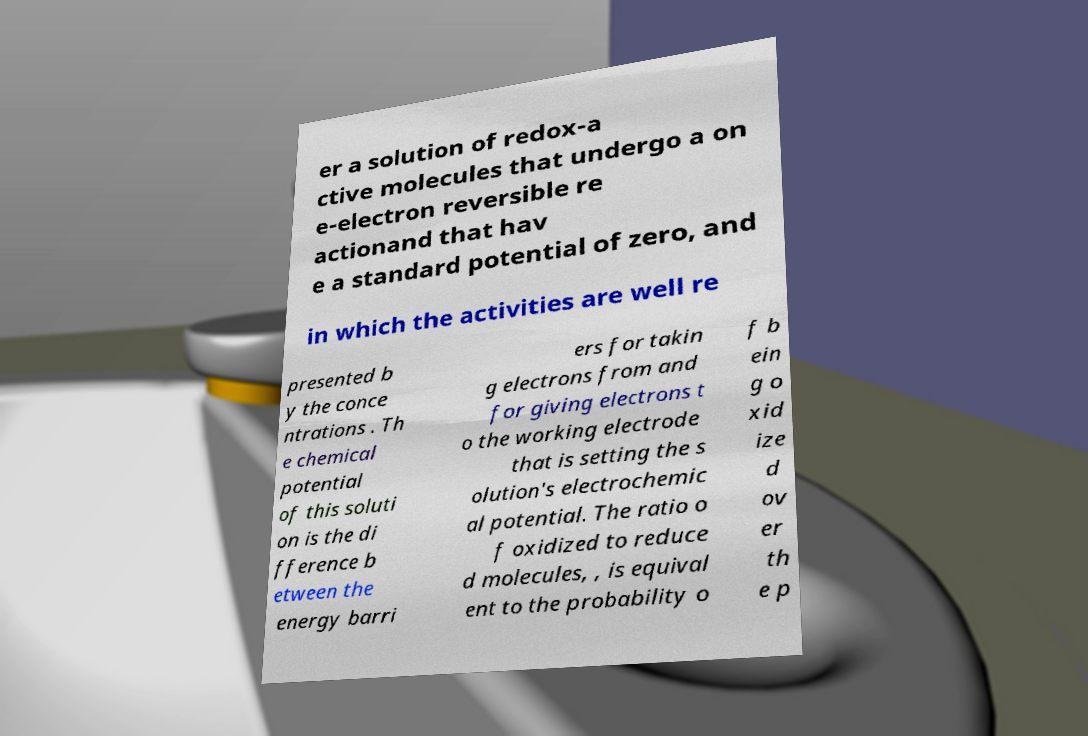Please read and relay the text visible in this image. What does it say? er a solution of redox-a ctive molecules that undergo a on e-electron reversible re actionand that hav e a standard potential of zero, and in which the activities are well re presented b y the conce ntrations . Th e chemical potential of this soluti on is the di fference b etween the energy barri ers for takin g electrons from and for giving electrons t o the working electrode that is setting the s olution's electrochemic al potential. The ratio o f oxidized to reduce d molecules, , is equival ent to the probability o f b ein g o xid ize d ov er th e p 